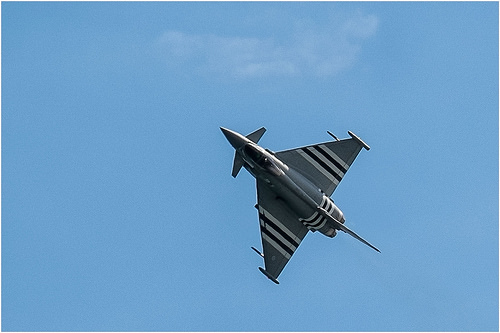<image>
Is the plane to the right of the sky? No. The plane is not to the right of the sky. The horizontal positioning shows a different relationship. Where is the air plane in relation to the sky? Is it in the sky? Yes. The air plane is contained within or inside the sky, showing a containment relationship. 